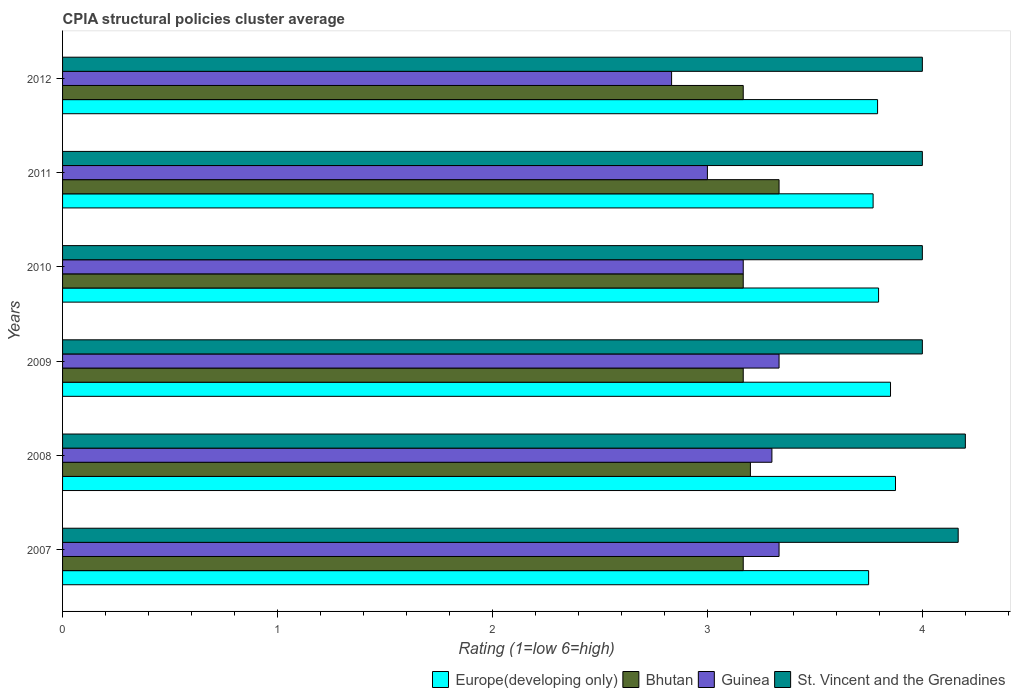How many groups of bars are there?
Ensure brevity in your answer.  6. How many bars are there on the 1st tick from the top?
Your answer should be very brief. 4. What is the label of the 3rd group of bars from the top?
Your answer should be compact. 2010. What is the CPIA rating in Guinea in 2009?
Make the answer very short. 3.33. Across all years, what is the maximum CPIA rating in Bhutan?
Your answer should be very brief. 3.33. Across all years, what is the minimum CPIA rating in St. Vincent and the Grenadines?
Your answer should be compact. 4. In which year was the CPIA rating in Europe(developing only) minimum?
Make the answer very short. 2007. What is the total CPIA rating in Bhutan in the graph?
Provide a succinct answer. 19.2. What is the difference between the CPIA rating in Guinea in 2010 and that in 2011?
Your response must be concise. 0.17. What is the difference between the CPIA rating in Europe(developing only) in 2009 and the CPIA rating in Bhutan in 2007?
Make the answer very short. 0.69. What is the average CPIA rating in Guinea per year?
Keep it short and to the point. 3.16. In the year 2012, what is the difference between the CPIA rating in Guinea and CPIA rating in Europe(developing only)?
Keep it short and to the point. -0.96. What is the ratio of the CPIA rating in Guinea in 2007 to that in 2010?
Make the answer very short. 1.05. Is the difference between the CPIA rating in Guinea in 2010 and 2011 greater than the difference between the CPIA rating in Europe(developing only) in 2010 and 2011?
Make the answer very short. Yes. What is the difference between the highest and the second highest CPIA rating in Europe(developing only)?
Your answer should be very brief. 0.02. What is the difference between the highest and the lowest CPIA rating in Bhutan?
Your response must be concise. 0.17. In how many years, is the CPIA rating in Bhutan greater than the average CPIA rating in Bhutan taken over all years?
Your answer should be very brief. 1. Is the sum of the CPIA rating in Europe(developing only) in 2007 and 2011 greater than the maximum CPIA rating in St. Vincent and the Grenadines across all years?
Offer a very short reply. Yes. Is it the case that in every year, the sum of the CPIA rating in Guinea and CPIA rating in Bhutan is greater than the sum of CPIA rating in Europe(developing only) and CPIA rating in St. Vincent and the Grenadines?
Give a very brief answer. No. What does the 3rd bar from the top in 2009 represents?
Offer a terse response. Bhutan. What does the 2nd bar from the bottom in 2012 represents?
Your answer should be compact. Bhutan. Is it the case that in every year, the sum of the CPIA rating in St. Vincent and the Grenadines and CPIA rating in Bhutan is greater than the CPIA rating in Europe(developing only)?
Ensure brevity in your answer.  Yes. Are all the bars in the graph horizontal?
Offer a very short reply. Yes. How many years are there in the graph?
Offer a very short reply. 6. What is the difference between two consecutive major ticks on the X-axis?
Provide a succinct answer. 1. Does the graph contain any zero values?
Make the answer very short. No. Does the graph contain grids?
Your answer should be very brief. No. How many legend labels are there?
Provide a succinct answer. 4. What is the title of the graph?
Your response must be concise. CPIA structural policies cluster average. Does "Cabo Verde" appear as one of the legend labels in the graph?
Offer a terse response. No. What is the label or title of the Y-axis?
Provide a succinct answer. Years. What is the Rating (1=low 6=high) of Europe(developing only) in 2007?
Your answer should be very brief. 3.75. What is the Rating (1=low 6=high) in Bhutan in 2007?
Keep it short and to the point. 3.17. What is the Rating (1=low 6=high) of Guinea in 2007?
Your response must be concise. 3.33. What is the Rating (1=low 6=high) of St. Vincent and the Grenadines in 2007?
Offer a very short reply. 4.17. What is the Rating (1=low 6=high) of Europe(developing only) in 2008?
Provide a succinct answer. 3.88. What is the Rating (1=low 6=high) of Bhutan in 2008?
Offer a very short reply. 3.2. What is the Rating (1=low 6=high) of Europe(developing only) in 2009?
Your response must be concise. 3.85. What is the Rating (1=low 6=high) of Bhutan in 2009?
Your response must be concise. 3.17. What is the Rating (1=low 6=high) in Guinea in 2009?
Keep it short and to the point. 3.33. What is the Rating (1=low 6=high) in Europe(developing only) in 2010?
Your response must be concise. 3.8. What is the Rating (1=low 6=high) of Bhutan in 2010?
Your answer should be very brief. 3.17. What is the Rating (1=low 6=high) of Guinea in 2010?
Offer a very short reply. 3.17. What is the Rating (1=low 6=high) of Europe(developing only) in 2011?
Make the answer very short. 3.77. What is the Rating (1=low 6=high) of Bhutan in 2011?
Provide a short and direct response. 3.33. What is the Rating (1=low 6=high) of Guinea in 2011?
Your answer should be very brief. 3. What is the Rating (1=low 6=high) in St. Vincent and the Grenadines in 2011?
Make the answer very short. 4. What is the Rating (1=low 6=high) in Europe(developing only) in 2012?
Offer a very short reply. 3.79. What is the Rating (1=low 6=high) of Bhutan in 2012?
Make the answer very short. 3.17. What is the Rating (1=low 6=high) in Guinea in 2012?
Give a very brief answer. 2.83. Across all years, what is the maximum Rating (1=low 6=high) of Europe(developing only)?
Provide a short and direct response. 3.88. Across all years, what is the maximum Rating (1=low 6=high) in Bhutan?
Offer a very short reply. 3.33. Across all years, what is the maximum Rating (1=low 6=high) of Guinea?
Make the answer very short. 3.33. Across all years, what is the minimum Rating (1=low 6=high) in Europe(developing only)?
Your answer should be very brief. 3.75. Across all years, what is the minimum Rating (1=low 6=high) of Bhutan?
Make the answer very short. 3.17. Across all years, what is the minimum Rating (1=low 6=high) in Guinea?
Keep it short and to the point. 2.83. Across all years, what is the minimum Rating (1=low 6=high) in St. Vincent and the Grenadines?
Your response must be concise. 4. What is the total Rating (1=low 6=high) of Europe(developing only) in the graph?
Provide a short and direct response. 22.84. What is the total Rating (1=low 6=high) in Guinea in the graph?
Keep it short and to the point. 18.97. What is the total Rating (1=low 6=high) of St. Vincent and the Grenadines in the graph?
Keep it short and to the point. 24.37. What is the difference between the Rating (1=low 6=high) of Europe(developing only) in 2007 and that in 2008?
Provide a short and direct response. -0.12. What is the difference between the Rating (1=low 6=high) in Bhutan in 2007 and that in 2008?
Your response must be concise. -0.03. What is the difference between the Rating (1=low 6=high) in Guinea in 2007 and that in 2008?
Offer a terse response. 0.03. What is the difference between the Rating (1=low 6=high) of St. Vincent and the Grenadines in 2007 and that in 2008?
Make the answer very short. -0.03. What is the difference between the Rating (1=low 6=high) of Europe(developing only) in 2007 and that in 2009?
Provide a succinct answer. -0.1. What is the difference between the Rating (1=low 6=high) of Bhutan in 2007 and that in 2009?
Ensure brevity in your answer.  0. What is the difference between the Rating (1=low 6=high) of Guinea in 2007 and that in 2009?
Offer a terse response. 0. What is the difference between the Rating (1=low 6=high) in St. Vincent and the Grenadines in 2007 and that in 2009?
Your answer should be compact. 0.17. What is the difference between the Rating (1=low 6=high) of Europe(developing only) in 2007 and that in 2010?
Make the answer very short. -0.05. What is the difference between the Rating (1=low 6=high) of Guinea in 2007 and that in 2010?
Offer a very short reply. 0.17. What is the difference between the Rating (1=low 6=high) of Europe(developing only) in 2007 and that in 2011?
Your answer should be very brief. -0.02. What is the difference between the Rating (1=low 6=high) of Bhutan in 2007 and that in 2011?
Your response must be concise. -0.17. What is the difference between the Rating (1=low 6=high) of St. Vincent and the Grenadines in 2007 and that in 2011?
Offer a very short reply. 0.17. What is the difference between the Rating (1=low 6=high) of Europe(developing only) in 2007 and that in 2012?
Give a very brief answer. -0.04. What is the difference between the Rating (1=low 6=high) of Europe(developing only) in 2008 and that in 2009?
Offer a terse response. 0.02. What is the difference between the Rating (1=low 6=high) of Guinea in 2008 and that in 2009?
Your answer should be compact. -0.03. What is the difference between the Rating (1=low 6=high) in St. Vincent and the Grenadines in 2008 and that in 2009?
Give a very brief answer. 0.2. What is the difference between the Rating (1=low 6=high) of Europe(developing only) in 2008 and that in 2010?
Your response must be concise. 0.08. What is the difference between the Rating (1=low 6=high) of Guinea in 2008 and that in 2010?
Your response must be concise. 0.13. What is the difference between the Rating (1=low 6=high) in St. Vincent and the Grenadines in 2008 and that in 2010?
Your answer should be very brief. 0.2. What is the difference between the Rating (1=low 6=high) in Europe(developing only) in 2008 and that in 2011?
Make the answer very short. 0.1. What is the difference between the Rating (1=low 6=high) in Bhutan in 2008 and that in 2011?
Ensure brevity in your answer.  -0.13. What is the difference between the Rating (1=low 6=high) in Europe(developing only) in 2008 and that in 2012?
Provide a short and direct response. 0.08. What is the difference between the Rating (1=low 6=high) of Guinea in 2008 and that in 2012?
Ensure brevity in your answer.  0.47. What is the difference between the Rating (1=low 6=high) in Europe(developing only) in 2009 and that in 2010?
Give a very brief answer. 0.06. What is the difference between the Rating (1=low 6=high) in Europe(developing only) in 2009 and that in 2011?
Ensure brevity in your answer.  0.08. What is the difference between the Rating (1=low 6=high) of Bhutan in 2009 and that in 2011?
Provide a short and direct response. -0.17. What is the difference between the Rating (1=low 6=high) of Guinea in 2009 and that in 2011?
Provide a short and direct response. 0.33. What is the difference between the Rating (1=low 6=high) in Europe(developing only) in 2009 and that in 2012?
Provide a succinct answer. 0.06. What is the difference between the Rating (1=low 6=high) in Bhutan in 2009 and that in 2012?
Give a very brief answer. 0. What is the difference between the Rating (1=low 6=high) in Guinea in 2009 and that in 2012?
Give a very brief answer. 0.5. What is the difference between the Rating (1=low 6=high) in Europe(developing only) in 2010 and that in 2011?
Offer a terse response. 0.03. What is the difference between the Rating (1=low 6=high) of Bhutan in 2010 and that in 2011?
Offer a very short reply. -0.17. What is the difference between the Rating (1=low 6=high) in St. Vincent and the Grenadines in 2010 and that in 2011?
Ensure brevity in your answer.  0. What is the difference between the Rating (1=low 6=high) of Europe(developing only) in 2010 and that in 2012?
Provide a succinct answer. 0. What is the difference between the Rating (1=low 6=high) of Bhutan in 2010 and that in 2012?
Keep it short and to the point. 0. What is the difference between the Rating (1=low 6=high) in Europe(developing only) in 2011 and that in 2012?
Give a very brief answer. -0.02. What is the difference between the Rating (1=low 6=high) in Guinea in 2011 and that in 2012?
Ensure brevity in your answer.  0.17. What is the difference between the Rating (1=low 6=high) of Europe(developing only) in 2007 and the Rating (1=low 6=high) of Bhutan in 2008?
Provide a short and direct response. 0.55. What is the difference between the Rating (1=low 6=high) in Europe(developing only) in 2007 and the Rating (1=low 6=high) in Guinea in 2008?
Ensure brevity in your answer.  0.45. What is the difference between the Rating (1=low 6=high) in Europe(developing only) in 2007 and the Rating (1=low 6=high) in St. Vincent and the Grenadines in 2008?
Your answer should be very brief. -0.45. What is the difference between the Rating (1=low 6=high) in Bhutan in 2007 and the Rating (1=low 6=high) in Guinea in 2008?
Give a very brief answer. -0.13. What is the difference between the Rating (1=low 6=high) of Bhutan in 2007 and the Rating (1=low 6=high) of St. Vincent and the Grenadines in 2008?
Make the answer very short. -1.03. What is the difference between the Rating (1=low 6=high) of Guinea in 2007 and the Rating (1=low 6=high) of St. Vincent and the Grenadines in 2008?
Ensure brevity in your answer.  -0.87. What is the difference between the Rating (1=low 6=high) of Europe(developing only) in 2007 and the Rating (1=low 6=high) of Bhutan in 2009?
Keep it short and to the point. 0.58. What is the difference between the Rating (1=low 6=high) of Europe(developing only) in 2007 and the Rating (1=low 6=high) of Guinea in 2009?
Your answer should be very brief. 0.42. What is the difference between the Rating (1=low 6=high) of Europe(developing only) in 2007 and the Rating (1=low 6=high) of St. Vincent and the Grenadines in 2009?
Your answer should be compact. -0.25. What is the difference between the Rating (1=low 6=high) in Bhutan in 2007 and the Rating (1=low 6=high) in Guinea in 2009?
Keep it short and to the point. -0.17. What is the difference between the Rating (1=low 6=high) of Bhutan in 2007 and the Rating (1=low 6=high) of St. Vincent and the Grenadines in 2009?
Make the answer very short. -0.83. What is the difference between the Rating (1=low 6=high) in Guinea in 2007 and the Rating (1=low 6=high) in St. Vincent and the Grenadines in 2009?
Ensure brevity in your answer.  -0.67. What is the difference between the Rating (1=low 6=high) in Europe(developing only) in 2007 and the Rating (1=low 6=high) in Bhutan in 2010?
Your answer should be compact. 0.58. What is the difference between the Rating (1=low 6=high) of Europe(developing only) in 2007 and the Rating (1=low 6=high) of Guinea in 2010?
Ensure brevity in your answer.  0.58. What is the difference between the Rating (1=low 6=high) in Bhutan in 2007 and the Rating (1=low 6=high) in Guinea in 2010?
Keep it short and to the point. 0. What is the difference between the Rating (1=low 6=high) of Bhutan in 2007 and the Rating (1=low 6=high) of St. Vincent and the Grenadines in 2010?
Keep it short and to the point. -0.83. What is the difference between the Rating (1=low 6=high) in Guinea in 2007 and the Rating (1=low 6=high) in St. Vincent and the Grenadines in 2010?
Ensure brevity in your answer.  -0.67. What is the difference between the Rating (1=low 6=high) of Europe(developing only) in 2007 and the Rating (1=low 6=high) of Bhutan in 2011?
Give a very brief answer. 0.42. What is the difference between the Rating (1=low 6=high) in Bhutan in 2007 and the Rating (1=low 6=high) in St. Vincent and the Grenadines in 2011?
Provide a short and direct response. -0.83. What is the difference between the Rating (1=low 6=high) in Europe(developing only) in 2007 and the Rating (1=low 6=high) in Bhutan in 2012?
Your answer should be compact. 0.58. What is the difference between the Rating (1=low 6=high) of Europe(developing only) in 2007 and the Rating (1=low 6=high) of Guinea in 2012?
Offer a very short reply. 0.92. What is the difference between the Rating (1=low 6=high) of Europe(developing only) in 2007 and the Rating (1=low 6=high) of St. Vincent and the Grenadines in 2012?
Make the answer very short. -0.25. What is the difference between the Rating (1=low 6=high) of Bhutan in 2007 and the Rating (1=low 6=high) of Guinea in 2012?
Provide a succinct answer. 0.33. What is the difference between the Rating (1=low 6=high) in Bhutan in 2007 and the Rating (1=low 6=high) in St. Vincent and the Grenadines in 2012?
Your answer should be compact. -0.83. What is the difference between the Rating (1=low 6=high) in Europe(developing only) in 2008 and the Rating (1=low 6=high) in Bhutan in 2009?
Offer a very short reply. 0.71. What is the difference between the Rating (1=low 6=high) of Europe(developing only) in 2008 and the Rating (1=low 6=high) of Guinea in 2009?
Ensure brevity in your answer.  0.54. What is the difference between the Rating (1=low 6=high) in Europe(developing only) in 2008 and the Rating (1=low 6=high) in St. Vincent and the Grenadines in 2009?
Offer a terse response. -0.12. What is the difference between the Rating (1=low 6=high) of Bhutan in 2008 and the Rating (1=low 6=high) of Guinea in 2009?
Offer a terse response. -0.13. What is the difference between the Rating (1=low 6=high) of Bhutan in 2008 and the Rating (1=low 6=high) of St. Vincent and the Grenadines in 2009?
Provide a succinct answer. -0.8. What is the difference between the Rating (1=low 6=high) of Europe(developing only) in 2008 and the Rating (1=low 6=high) of Bhutan in 2010?
Your answer should be compact. 0.71. What is the difference between the Rating (1=low 6=high) in Europe(developing only) in 2008 and the Rating (1=low 6=high) in Guinea in 2010?
Your answer should be compact. 0.71. What is the difference between the Rating (1=low 6=high) of Europe(developing only) in 2008 and the Rating (1=low 6=high) of St. Vincent and the Grenadines in 2010?
Offer a terse response. -0.12. What is the difference between the Rating (1=low 6=high) in Bhutan in 2008 and the Rating (1=low 6=high) in St. Vincent and the Grenadines in 2010?
Your response must be concise. -0.8. What is the difference between the Rating (1=low 6=high) of Europe(developing only) in 2008 and the Rating (1=low 6=high) of Bhutan in 2011?
Provide a succinct answer. 0.54. What is the difference between the Rating (1=low 6=high) of Europe(developing only) in 2008 and the Rating (1=low 6=high) of Guinea in 2011?
Offer a very short reply. 0.88. What is the difference between the Rating (1=low 6=high) in Europe(developing only) in 2008 and the Rating (1=low 6=high) in St. Vincent and the Grenadines in 2011?
Your answer should be compact. -0.12. What is the difference between the Rating (1=low 6=high) of Bhutan in 2008 and the Rating (1=low 6=high) of St. Vincent and the Grenadines in 2011?
Your answer should be very brief. -0.8. What is the difference between the Rating (1=low 6=high) in Europe(developing only) in 2008 and the Rating (1=low 6=high) in Bhutan in 2012?
Make the answer very short. 0.71. What is the difference between the Rating (1=low 6=high) in Europe(developing only) in 2008 and the Rating (1=low 6=high) in Guinea in 2012?
Provide a succinct answer. 1.04. What is the difference between the Rating (1=low 6=high) in Europe(developing only) in 2008 and the Rating (1=low 6=high) in St. Vincent and the Grenadines in 2012?
Your answer should be very brief. -0.12. What is the difference between the Rating (1=low 6=high) of Bhutan in 2008 and the Rating (1=low 6=high) of Guinea in 2012?
Offer a terse response. 0.37. What is the difference between the Rating (1=low 6=high) of Europe(developing only) in 2009 and the Rating (1=low 6=high) of Bhutan in 2010?
Your answer should be compact. 0.69. What is the difference between the Rating (1=low 6=high) in Europe(developing only) in 2009 and the Rating (1=low 6=high) in Guinea in 2010?
Offer a terse response. 0.69. What is the difference between the Rating (1=low 6=high) in Europe(developing only) in 2009 and the Rating (1=low 6=high) in St. Vincent and the Grenadines in 2010?
Your answer should be very brief. -0.15. What is the difference between the Rating (1=low 6=high) in Bhutan in 2009 and the Rating (1=low 6=high) in St. Vincent and the Grenadines in 2010?
Your answer should be very brief. -0.83. What is the difference between the Rating (1=low 6=high) of Guinea in 2009 and the Rating (1=low 6=high) of St. Vincent and the Grenadines in 2010?
Your answer should be compact. -0.67. What is the difference between the Rating (1=low 6=high) of Europe(developing only) in 2009 and the Rating (1=low 6=high) of Bhutan in 2011?
Make the answer very short. 0.52. What is the difference between the Rating (1=low 6=high) in Europe(developing only) in 2009 and the Rating (1=low 6=high) in Guinea in 2011?
Provide a succinct answer. 0.85. What is the difference between the Rating (1=low 6=high) of Europe(developing only) in 2009 and the Rating (1=low 6=high) of St. Vincent and the Grenadines in 2011?
Your answer should be compact. -0.15. What is the difference between the Rating (1=low 6=high) of Bhutan in 2009 and the Rating (1=low 6=high) of Guinea in 2011?
Ensure brevity in your answer.  0.17. What is the difference between the Rating (1=low 6=high) of Guinea in 2009 and the Rating (1=low 6=high) of St. Vincent and the Grenadines in 2011?
Make the answer very short. -0.67. What is the difference between the Rating (1=low 6=high) in Europe(developing only) in 2009 and the Rating (1=low 6=high) in Bhutan in 2012?
Offer a very short reply. 0.69. What is the difference between the Rating (1=low 6=high) in Europe(developing only) in 2009 and the Rating (1=low 6=high) in Guinea in 2012?
Provide a succinct answer. 1.02. What is the difference between the Rating (1=low 6=high) of Europe(developing only) in 2009 and the Rating (1=low 6=high) of St. Vincent and the Grenadines in 2012?
Offer a terse response. -0.15. What is the difference between the Rating (1=low 6=high) in Guinea in 2009 and the Rating (1=low 6=high) in St. Vincent and the Grenadines in 2012?
Provide a short and direct response. -0.67. What is the difference between the Rating (1=low 6=high) in Europe(developing only) in 2010 and the Rating (1=low 6=high) in Bhutan in 2011?
Provide a succinct answer. 0.46. What is the difference between the Rating (1=low 6=high) in Europe(developing only) in 2010 and the Rating (1=low 6=high) in Guinea in 2011?
Your answer should be very brief. 0.8. What is the difference between the Rating (1=low 6=high) of Europe(developing only) in 2010 and the Rating (1=low 6=high) of St. Vincent and the Grenadines in 2011?
Ensure brevity in your answer.  -0.2. What is the difference between the Rating (1=low 6=high) in Guinea in 2010 and the Rating (1=low 6=high) in St. Vincent and the Grenadines in 2011?
Offer a terse response. -0.83. What is the difference between the Rating (1=low 6=high) in Europe(developing only) in 2010 and the Rating (1=low 6=high) in Bhutan in 2012?
Offer a very short reply. 0.63. What is the difference between the Rating (1=low 6=high) of Europe(developing only) in 2010 and the Rating (1=low 6=high) of Guinea in 2012?
Offer a very short reply. 0.96. What is the difference between the Rating (1=low 6=high) in Europe(developing only) in 2010 and the Rating (1=low 6=high) in St. Vincent and the Grenadines in 2012?
Keep it short and to the point. -0.2. What is the difference between the Rating (1=low 6=high) in Europe(developing only) in 2011 and the Rating (1=low 6=high) in Bhutan in 2012?
Offer a terse response. 0.6. What is the difference between the Rating (1=low 6=high) in Europe(developing only) in 2011 and the Rating (1=low 6=high) in Guinea in 2012?
Give a very brief answer. 0.94. What is the difference between the Rating (1=low 6=high) in Europe(developing only) in 2011 and the Rating (1=low 6=high) in St. Vincent and the Grenadines in 2012?
Your answer should be compact. -0.23. What is the difference between the Rating (1=low 6=high) of Bhutan in 2011 and the Rating (1=low 6=high) of Guinea in 2012?
Offer a very short reply. 0.5. What is the average Rating (1=low 6=high) of Europe(developing only) per year?
Provide a succinct answer. 3.81. What is the average Rating (1=low 6=high) of Bhutan per year?
Offer a very short reply. 3.2. What is the average Rating (1=low 6=high) of Guinea per year?
Keep it short and to the point. 3.16. What is the average Rating (1=low 6=high) in St. Vincent and the Grenadines per year?
Give a very brief answer. 4.06. In the year 2007, what is the difference between the Rating (1=low 6=high) of Europe(developing only) and Rating (1=low 6=high) of Bhutan?
Your response must be concise. 0.58. In the year 2007, what is the difference between the Rating (1=low 6=high) in Europe(developing only) and Rating (1=low 6=high) in Guinea?
Give a very brief answer. 0.42. In the year 2007, what is the difference between the Rating (1=low 6=high) in Europe(developing only) and Rating (1=low 6=high) in St. Vincent and the Grenadines?
Your answer should be very brief. -0.42. In the year 2007, what is the difference between the Rating (1=low 6=high) in Bhutan and Rating (1=low 6=high) in Guinea?
Offer a very short reply. -0.17. In the year 2007, what is the difference between the Rating (1=low 6=high) of Bhutan and Rating (1=low 6=high) of St. Vincent and the Grenadines?
Offer a terse response. -1. In the year 2008, what is the difference between the Rating (1=low 6=high) of Europe(developing only) and Rating (1=low 6=high) of Bhutan?
Make the answer very short. 0.68. In the year 2008, what is the difference between the Rating (1=low 6=high) in Europe(developing only) and Rating (1=low 6=high) in Guinea?
Ensure brevity in your answer.  0.57. In the year 2008, what is the difference between the Rating (1=low 6=high) of Europe(developing only) and Rating (1=low 6=high) of St. Vincent and the Grenadines?
Ensure brevity in your answer.  -0.33. In the year 2008, what is the difference between the Rating (1=low 6=high) in Guinea and Rating (1=low 6=high) in St. Vincent and the Grenadines?
Offer a very short reply. -0.9. In the year 2009, what is the difference between the Rating (1=low 6=high) of Europe(developing only) and Rating (1=low 6=high) of Bhutan?
Offer a terse response. 0.69. In the year 2009, what is the difference between the Rating (1=low 6=high) in Europe(developing only) and Rating (1=low 6=high) in Guinea?
Your answer should be very brief. 0.52. In the year 2009, what is the difference between the Rating (1=low 6=high) in Europe(developing only) and Rating (1=low 6=high) in St. Vincent and the Grenadines?
Provide a succinct answer. -0.15. In the year 2009, what is the difference between the Rating (1=low 6=high) in Bhutan and Rating (1=low 6=high) in St. Vincent and the Grenadines?
Provide a succinct answer. -0.83. In the year 2010, what is the difference between the Rating (1=low 6=high) in Europe(developing only) and Rating (1=low 6=high) in Bhutan?
Provide a succinct answer. 0.63. In the year 2010, what is the difference between the Rating (1=low 6=high) in Europe(developing only) and Rating (1=low 6=high) in Guinea?
Provide a short and direct response. 0.63. In the year 2010, what is the difference between the Rating (1=low 6=high) in Europe(developing only) and Rating (1=low 6=high) in St. Vincent and the Grenadines?
Offer a very short reply. -0.2. In the year 2010, what is the difference between the Rating (1=low 6=high) in Bhutan and Rating (1=low 6=high) in St. Vincent and the Grenadines?
Provide a succinct answer. -0.83. In the year 2010, what is the difference between the Rating (1=low 6=high) of Guinea and Rating (1=low 6=high) of St. Vincent and the Grenadines?
Provide a succinct answer. -0.83. In the year 2011, what is the difference between the Rating (1=low 6=high) in Europe(developing only) and Rating (1=low 6=high) in Bhutan?
Ensure brevity in your answer.  0.44. In the year 2011, what is the difference between the Rating (1=low 6=high) in Europe(developing only) and Rating (1=low 6=high) in Guinea?
Provide a short and direct response. 0.77. In the year 2011, what is the difference between the Rating (1=low 6=high) of Europe(developing only) and Rating (1=low 6=high) of St. Vincent and the Grenadines?
Your answer should be compact. -0.23. In the year 2011, what is the difference between the Rating (1=low 6=high) in Guinea and Rating (1=low 6=high) in St. Vincent and the Grenadines?
Provide a short and direct response. -1. In the year 2012, what is the difference between the Rating (1=low 6=high) of Europe(developing only) and Rating (1=low 6=high) of Guinea?
Provide a succinct answer. 0.96. In the year 2012, what is the difference between the Rating (1=low 6=high) of Europe(developing only) and Rating (1=low 6=high) of St. Vincent and the Grenadines?
Your response must be concise. -0.21. In the year 2012, what is the difference between the Rating (1=low 6=high) in Guinea and Rating (1=low 6=high) in St. Vincent and the Grenadines?
Offer a very short reply. -1.17. What is the ratio of the Rating (1=low 6=high) of Bhutan in 2007 to that in 2008?
Provide a succinct answer. 0.99. What is the ratio of the Rating (1=low 6=high) in St. Vincent and the Grenadines in 2007 to that in 2008?
Provide a short and direct response. 0.99. What is the ratio of the Rating (1=low 6=high) of Europe(developing only) in 2007 to that in 2009?
Keep it short and to the point. 0.97. What is the ratio of the Rating (1=low 6=high) of St. Vincent and the Grenadines in 2007 to that in 2009?
Make the answer very short. 1.04. What is the ratio of the Rating (1=low 6=high) of Europe(developing only) in 2007 to that in 2010?
Your answer should be very brief. 0.99. What is the ratio of the Rating (1=low 6=high) in Guinea in 2007 to that in 2010?
Make the answer very short. 1.05. What is the ratio of the Rating (1=low 6=high) of St. Vincent and the Grenadines in 2007 to that in 2010?
Offer a terse response. 1.04. What is the ratio of the Rating (1=low 6=high) in St. Vincent and the Grenadines in 2007 to that in 2011?
Provide a succinct answer. 1.04. What is the ratio of the Rating (1=low 6=high) in Europe(developing only) in 2007 to that in 2012?
Your response must be concise. 0.99. What is the ratio of the Rating (1=low 6=high) of Bhutan in 2007 to that in 2012?
Provide a succinct answer. 1. What is the ratio of the Rating (1=low 6=high) of Guinea in 2007 to that in 2012?
Give a very brief answer. 1.18. What is the ratio of the Rating (1=low 6=high) of St. Vincent and the Grenadines in 2007 to that in 2012?
Ensure brevity in your answer.  1.04. What is the ratio of the Rating (1=low 6=high) in Europe(developing only) in 2008 to that in 2009?
Offer a very short reply. 1.01. What is the ratio of the Rating (1=low 6=high) in Bhutan in 2008 to that in 2009?
Your response must be concise. 1.01. What is the ratio of the Rating (1=low 6=high) in Europe(developing only) in 2008 to that in 2010?
Your answer should be very brief. 1.02. What is the ratio of the Rating (1=low 6=high) of Bhutan in 2008 to that in 2010?
Give a very brief answer. 1.01. What is the ratio of the Rating (1=low 6=high) in Guinea in 2008 to that in 2010?
Your answer should be compact. 1.04. What is the ratio of the Rating (1=low 6=high) of Europe(developing only) in 2008 to that in 2011?
Your answer should be very brief. 1.03. What is the ratio of the Rating (1=low 6=high) of Guinea in 2008 to that in 2011?
Offer a very short reply. 1.1. What is the ratio of the Rating (1=low 6=high) in Europe(developing only) in 2008 to that in 2012?
Your response must be concise. 1.02. What is the ratio of the Rating (1=low 6=high) in Bhutan in 2008 to that in 2012?
Keep it short and to the point. 1.01. What is the ratio of the Rating (1=low 6=high) of Guinea in 2008 to that in 2012?
Your answer should be very brief. 1.16. What is the ratio of the Rating (1=low 6=high) of Europe(developing only) in 2009 to that in 2010?
Provide a succinct answer. 1.01. What is the ratio of the Rating (1=low 6=high) in Bhutan in 2009 to that in 2010?
Offer a very short reply. 1. What is the ratio of the Rating (1=low 6=high) in Guinea in 2009 to that in 2010?
Offer a terse response. 1.05. What is the ratio of the Rating (1=low 6=high) in Europe(developing only) in 2009 to that in 2011?
Your response must be concise. 1.02. What is the ratio of the Rating (1=low 6=high) of Bhutan in 2009 to that in 2011?
Keep it short and to the point. 0.95. What is the ratio of the Rating (1=low 6=high) of St. Vincent and the Grenadines in 2009 to that in 2011?
Make the answer very short. 1. What is the ratio of the Rating (1=low 6=high) of Europe(developing only) in 2009 to that in 2012?
Your response must be concise. 1.02. What is the ratio of the Rating (1=low 6=high) of Guinea in 2009 to that in 2012?
Make the answer very short. 1.18. What is the ratio of the Rating (1=low 6=high) of St. Vincent and the Grenadines in 2009 to that in 2012?
Your answer should be compact. 1. What is the ratio of the Rating (1=low 6=high) in Europe(developing only) in 2010 to that in 2011?
Your answer should be very brief. 1.01. What is the ratio of the Rating (1=low 6=high) in Guinea in 2010 to that in 2011?
Provide a succinct answer. 1.06. What is the ratio of the Rating (1=low 6=high) of Europe(developing only) in 2010 to that in 2012?
Keep it short and to the point. 1. What is the ratio of the Rating (1=low 6=high) in Bhutan in 2010 to that in 2012?
Your response must be concise. 1. What is the ratio of the Rating (1=low 6=high) in Guinea in 2010 to that in 2012?
Keep it short and to the point. 1.12. What is the ratio of the Rating (1=low 6=high) in Europe(developing only) in 2011 to that in 2012?
Give a very brief answer. 0.99. What is the ratio of the Rating (1=low 6=high) in Bhutan in 2011 to that in 2012?
Provide a succinct answer. 1.05. What is the ratio of the Rating (1=low 6=high) in Guinea in 2011 to that in 2012?
Provide a short and direct response. 1.06. What is the difference between the highest and the second highest Rating (1=low 6=high) in Europe(developing only)?
Your response must be concise. 0.02. What is the difference between the highest and the second highest Rating (1=low 6=high) of Bhutan?
Give a very brief answer. 0.13. What is the difference between the highest and the second highest Rating (1=low 6=high) in Guinea?
Your response must be concise. 0. What is the difference between the highest and the second highest Rating (1=low 6=high) in St. Vincent and the Grenadines?
Offer a terse response. 0.03. What is the difference between the highest and the lowest Rating (1=low 6=high) in Bhutan?
Your response must be concise. 0.17. What is the difference between the highest and the lowest Rating (1=low 6=high) in St. Vincent and the Grenadines?
Make the answer very short. 0.2. 